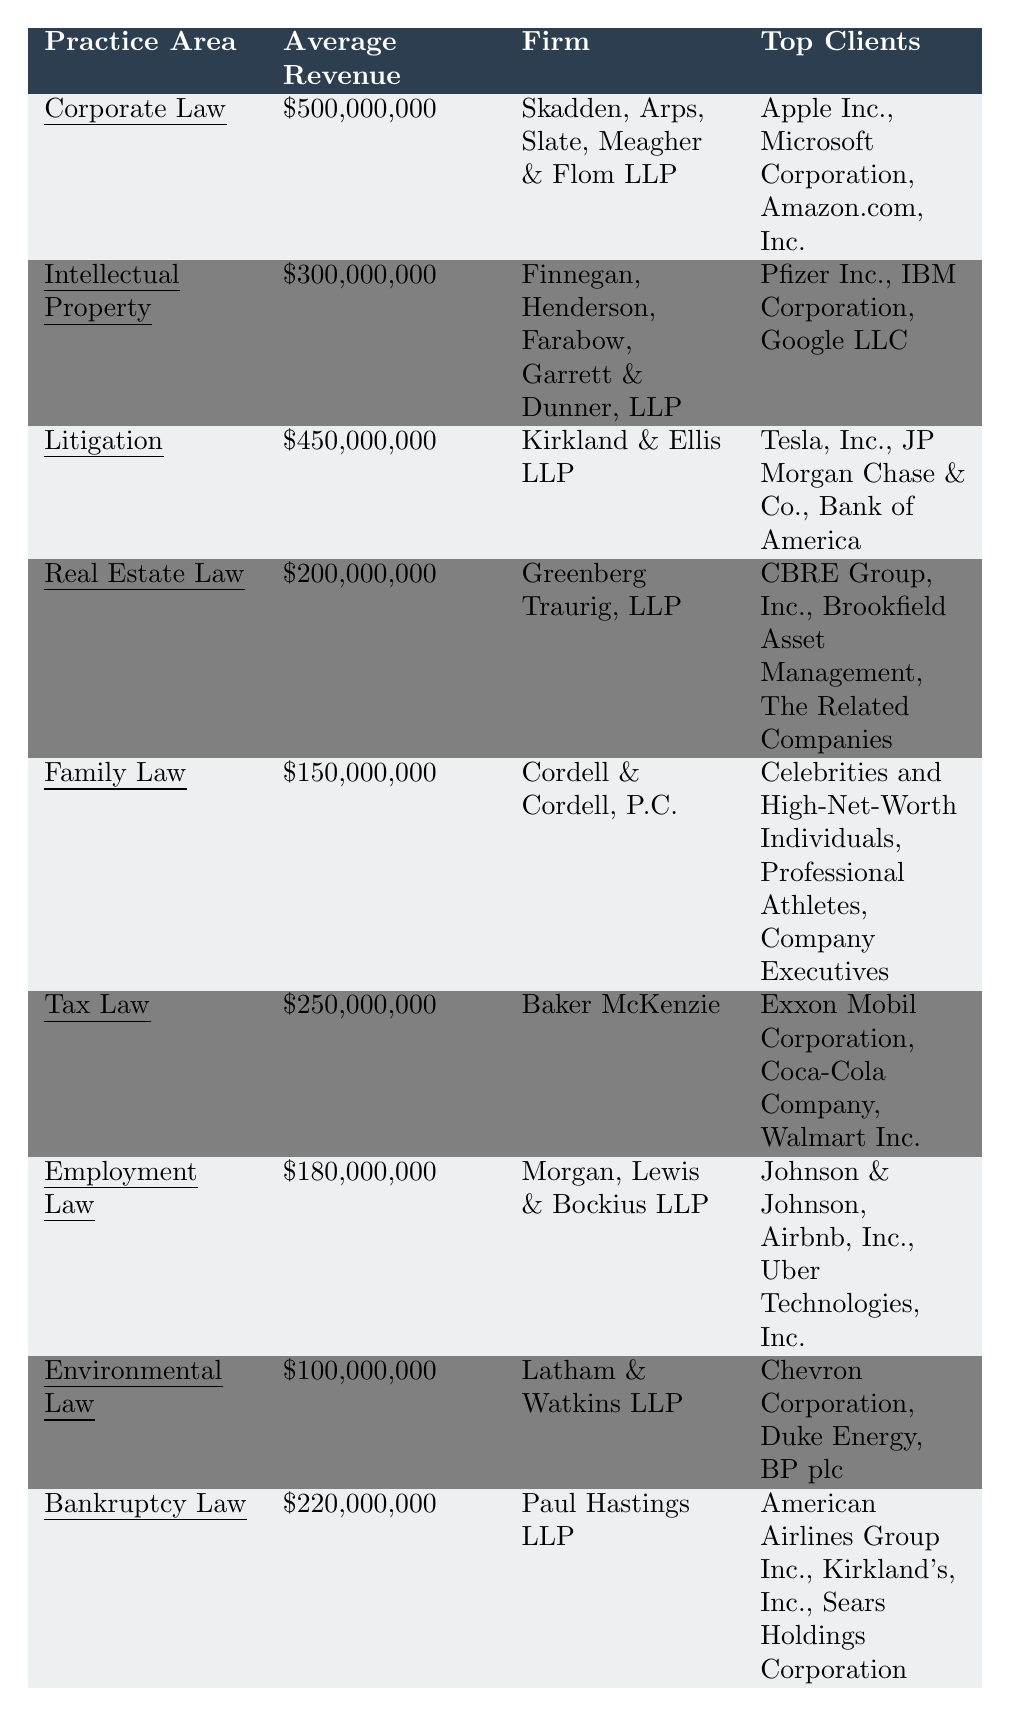What is the average revenue for the practice area of Litigation? The average revenue for Litigation is listed in the table as $450,000,000.
Answer: $450,000,000 Which firm specializes in Environmental Law? According to the table, Latham & Watkins LLP specializes in Environmental Law.
Answer: Latham & Watkins LLP What is the total average revenue of the practice areas: Tax Law, Employment Law, and Family Law? The average revenue for Tax Law is $250,000,000, Employment Law is $180,000,000, and Family Law is $150,000,000. Adding these gives $250,000,000 + $180,000,000 + $150,000,000 = $580,000,000.
Answer: $580,000,000 Is the average revenue for Real Estate Law greater than that of Family Law? The average revenue for Real Estate Law is $200,000,000, while Family Law has an average revenue of $150,000,000. $200,000,000 is greater than $150,000,000.
Answer: Yes Which practice area has the lowest average revenue? The average revenue for Environmental Law is listed as $100,000,000, which is lower than the other listed practice areas.
Answer: Environmental Law What is the combined average revenue of Corporate Law and Litigation? Corporate Law has an average revenue of $500,000,000 and Litigation has an average revenue of $450,000,000. Adding these gives $500,000,000 + $450,000,000 = $950,000,000.
Answer: $950,000,000 How many top clients does Baker McKenzie have? The table lists three top clients for Baker McKenzie under Tax Law: Exxon Mobil Corporation, Coca-Cola Company, and Walmart Inc.
Answer: 3 Which firm has the highest average revenue and what is that revenue? The firm with the highest average revenue is Skadden, Arps, Slate, Meagher & Flom LLP that specializes in Corporate Law with an average revenue of $500,000,000.
Answer: Skadden, Arps, Slate, Meagher & Flom LLP, $500,000,000 What is the average revenue for Bankruptcy Law compared to Environmental Law? Bankruptcy Law has an average revenue of $220,000,000, while Environmental Law has $100,000,000. Comparing these values shows that $220,000,000 is greater than $100,000,000.
Answer: Bankruptcy Law is greater If we combine the average revenues of Real Estate Law and Employment Law, what is the result? The average revenue for Real Estate Law is $200,000,000 and for Employment Law is $180,000,000. Adding these gives $200,000,000 + $180,000,000 = $380,000,000.
Answer: $380,000,000 